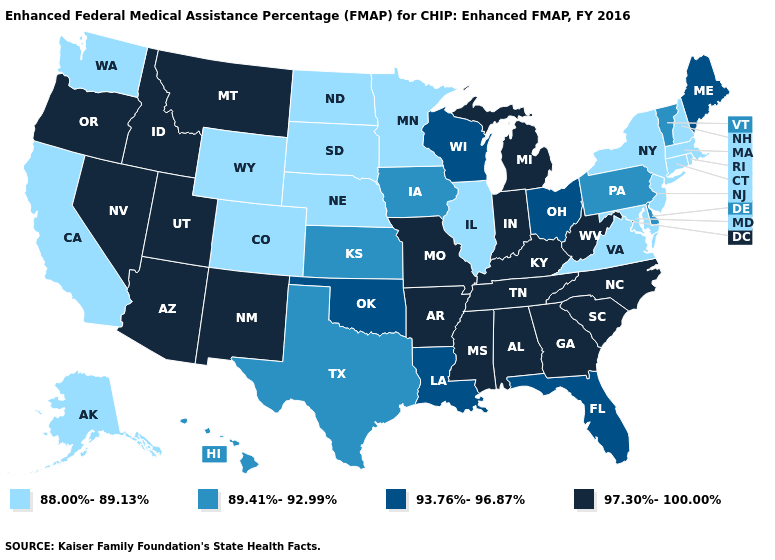Name the states that have a value in the range 88.00%-89.13%?
Keep it brief. Alaska, California, Colorado, Connecticut, Illinois, Maryland, Massachusetts, Minnesota, Nebraska, New Hampshire, New Jersey, New York, North Dakota, Rhode Island, South Dakota, Virginia, Washington, Wyoming. What is the value of Colorado?
Quick response, please. 88.00%-89.13%. Does the first symbol in the legend represent the smallest category?
Give a very brief answer. Yes. Does New Jersey have the same value as Hawaii?
Answer briefly. No. Name the states that have a value in the range 97.30%-100.00%?
Keep it brief. Alabama, Arizona, Arkansas, Georgia, Idaho, Indiana, Kentucky, Michigan, Mississippi, Missouri, Montana, Nevada, New Mexico, North Carolina, Oregon, South Carolina, Tennessee, Utah, West Virginia. What is the value of Delaware?
Quick response, please. 89.41%-92.99%. What is the highest value in the Northeast ?
Answer briefly. 93.76%-96.87%. Name the states that have a value in the range 93.76%-96.87%?
Write a very short answer. Florida, Louisiana, Maine, Ohio, Oklahoma, Wisconsin. Is the legend a continuous bar?
Give a very brief answer. No. What is the value of Connecticut?
Answer briefly. 88.00%-89.13%. Which states hav the highest value in the South?
Give a very brief answer. Alabama, Arkansas, Georgia, Kentucky, Mississippi, North Carolina, South Carolina, Tennessee, West Virginia. Which states hav the highest value in the MidWest?
Write a very short answer. Indiana, Michigan, Missouri. Which states have the highest value in the USA?
Be succinct. Alabama, Arizona, Arkansas, Georgia, Idaho, Indiana, Kentucky, Michigan, Mississippi, Missouri, Montana, Nevada, New Mexico, North Carolina, Oregon, South Carolina, Tennessee, Utah, West Virginia. Name the states that have a value in the range 97.30%-100.00%?
Be succinct. Alabama, Arizona, Arkansas, Georgia, Idaho, Indiana, Kentucky, Michigan, Mississippi, Missouri, Montana, Nevada, New Mexico, North Carolina, Oregon, South Carolina, Tennessee, Utah, West Virginia. 